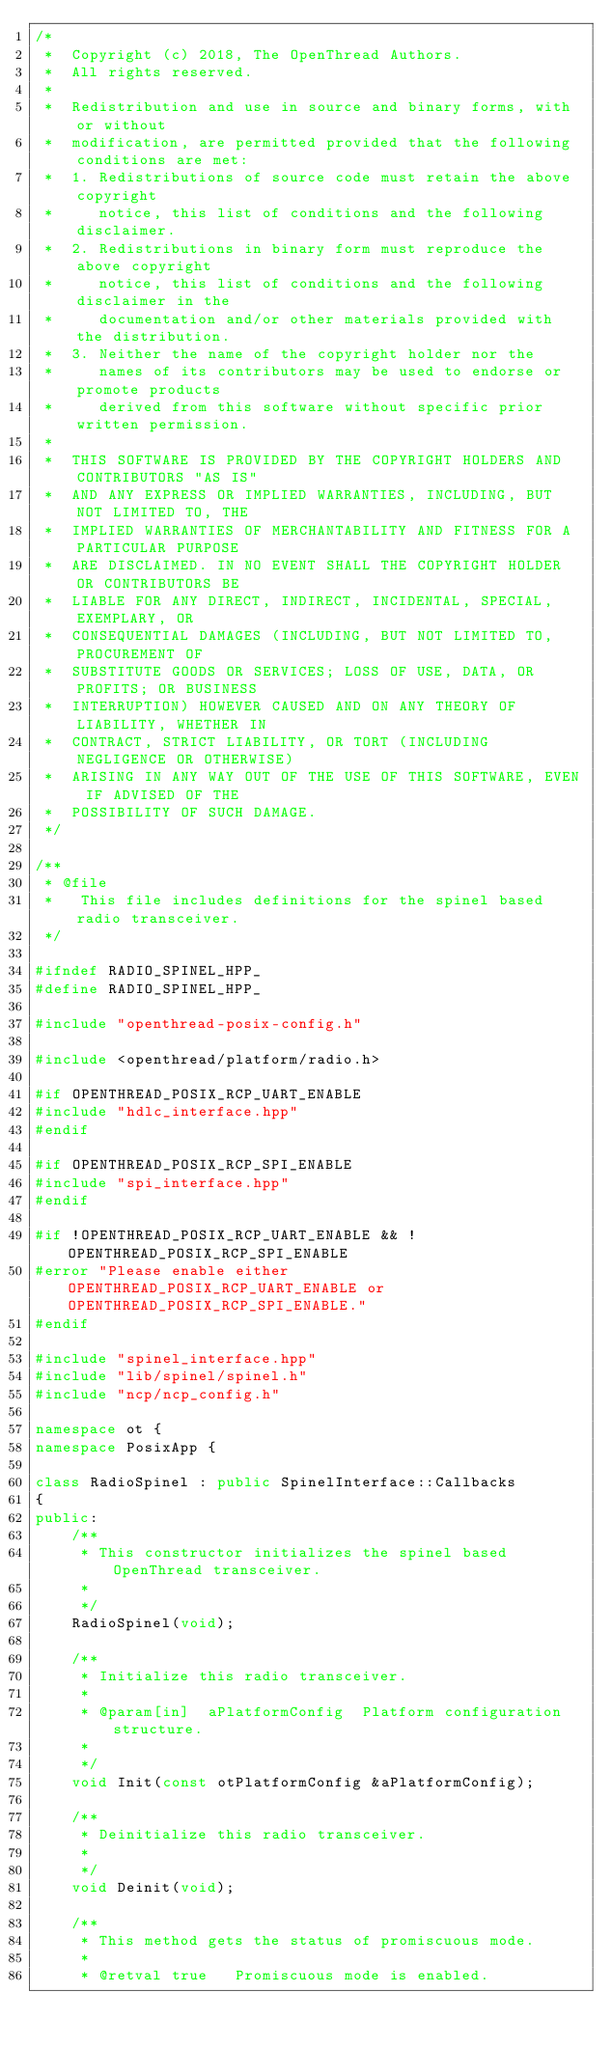Convert code to text. <code><loc_0><loc_0><loc_500><loc_500><_C++_>/*
 *  Copyright (c) 2018, The OpenThread Authors.
 *  All rights reserved.
 *
 *  Redistribution and use in source and binary forms, with or without
 *  modification, are permitted provided that the following conditions are met:
 *  1. Redistributions of source code must retain the above copyright
 *     notice, this list of conditions and the following disclaimer.
 *  2. Redistributions in binary form must reproduce the above copyright
 *     notice, this list of conditions and the following disclaimer in the
 *     documentation and/or other materials provided with the distribution.
 *  3. Neither the name of the copyright holder nor the
 *     names of its contributors may be used to endorse or promote products
 *     derived from this software without specific prior written permission.
 *
 *  THIS SOFTWARE IS PROVIDED BY THE COPYRIGHT HOLDERS AND CONTRIBUTORS "AS IS"
 *  AND ANY EXPRESS OR IMPLIED WARRANTIES, INCLUDING, BUT NOT LIMITED TO, THE
 *  IMPLIED WARRANTIES OF MERCHANTABILITY AND FITNESS FOR A PARTICULAR PURPOSE
 *  ARE DISCLAIMED. IN NO EVENT SHALL THE COPYRIGHT HOLDER OR CONTRIBUTORS BE
 *  LIABLE FOR ANY DIRECT, INDIRECT, INCIDENTAL, SPECIAL, EXEMPLARY, OR
 *  CONSEQUENTIAL DAMAGES (INCLUDING, BUT NOT LIMITED TO, PROCUREMENT OF
 *  SUBSTITUTE GOODS OR SERVICES; LOSS OF USE, DATA, OR PROFITS; OR BUSINESS
 *  INTERRUPTION) HOWEVER CAUSED AND ON ANY THEORY OF LIABILITY, WHETHER IN
 *  CONTRACT, STRICT LIABILITY, OR TORT (INCLUDING NEGLIGENCE OR OTHERWISE)
 *  ARISING IN ANY WAY OUT OF THE USE OF THIS SOFTWARE, EVEN IF ADVISED OF THE
 *  POSSIBILITY OF SUCH DAMAGE.
 */

/**
 * @file
 *   This file includes definitions for the spinel based radio transceiver.
 */

#ifndef RADIO_SPINEL_HPP_
#define RADIO_SPINEL_HPP_

#include "openthread-posix-config.h"

#include <openthread/platform/radio.h>

#if OPENTHREAD_POSIX_RCP_UART_ENABLE
#include "hdlc_interface.hpp"
#endif

#if OPENTHREAD_POSIX_RCP_SPI_ENABLE
#include "spi_interface.hpp"
#endif

#if !OPENTHREAD_POSIX_RCP_UART_ENABLE && !OPENTHREAD_POSIX_RCP_SPI_ENABLE
#error "Please enable either OPENTHREAD_POSIX_RCP_UART_ENABLE or OPENTHREAD_POSIX_RCP_SPI_ENABLE."
#endif

#include "spinel_interface.hpp"
#include "lib/spinel/spinel.h"
#include "ncp/ncp_config.h"

namespace ot {
namespace PosixApp {

class RadioSpinel : public SpinelInterface::Callbacks
{
public:
    /**
     * This constructor initializes the spinel based OpenThread transceiver.
     *
     */
    RadioSpinel(void);

    /**
     * Initialize this radio transceiver.
     *
     * @param[in]  aPlatformConfig  Platform configuration structure.
     *
     */
    void Init(const otPlatformConfig &aPlatformConfig);

    /**
     * Deinitialize this radio transceiver.
     *
     */
    void Deinit(void);

    /**
     * This method gets the status of promiscuous mode.
     *
     * @retval true   Promiscuous mode is enabled.</code> 